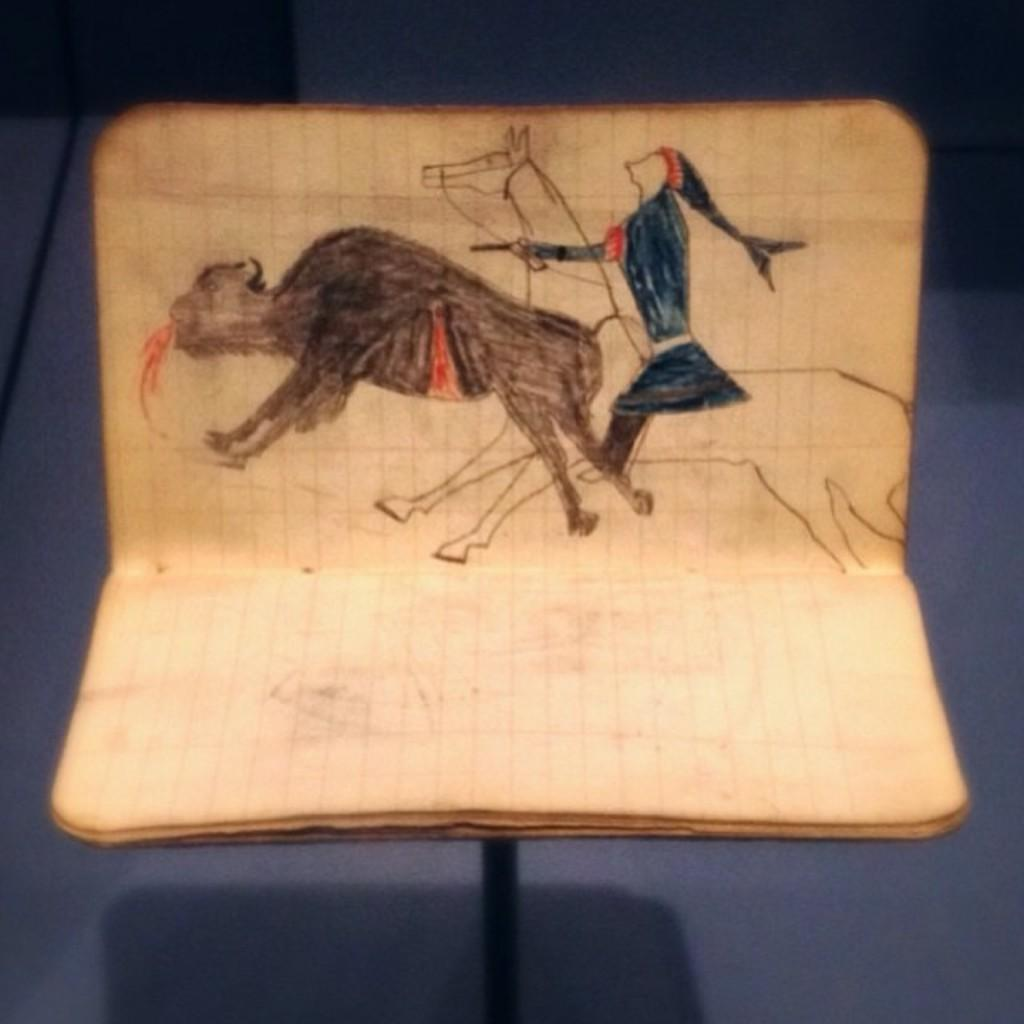What is the main subject in the center of the image? There is a book in the center of the image. What can be found inside the book? The book contains a drawing of a person and drawings of animals. How many rings are visible in the image? There are no rings present in the image. Is there a flame visible in the image? There is no flame present in the image. 